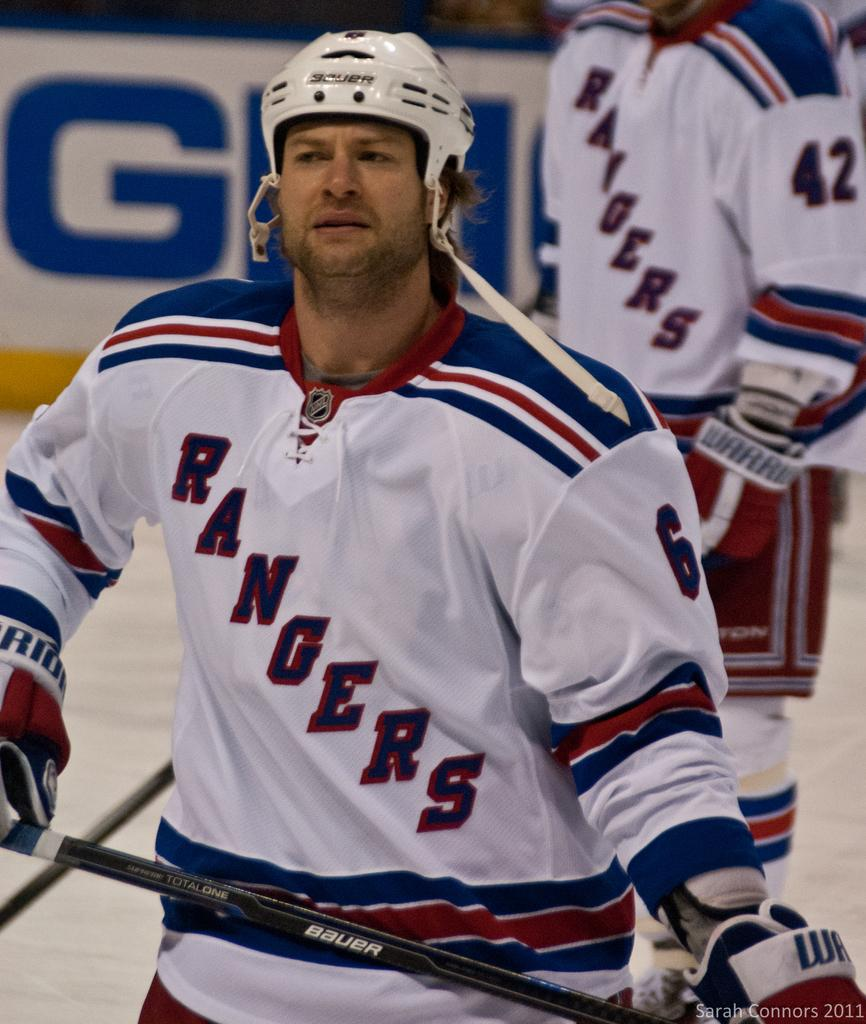What is the man in the image wearing on his head? The man is wearing a helmet. What else is the man wearing in the image? The man is wearing gloves. What is the man holding in his hand in the image? The man is holding a stick. Can you describe the person standing at the back of the man in the image? The person standing at the back of the man is on the ground. What can be seen in the background of the image? There is a poster visible in the image. What type of engine can be seen powering the man's movements in the image? There is no engine visible in the image, and the man's movements are not powered by an engine. 